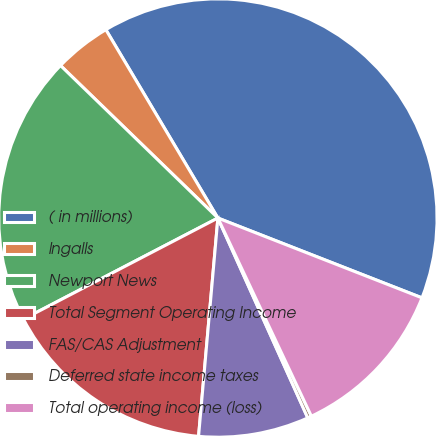Convert chart to OTSL. <chart><loc_0><loc_0><loc_500><loc_500><pie_chart><fcel>( in millions)<fcel>Ingalls<fcel>Newport News<fcel>Total Segment Operating Income<fcel>FAS/CAS Adjustment<fcel>Deferred state income taxes<fcel>Total operating income (loss)<nl><fcel>39.47%<fcel>4.21%<fcel>19.88%<fcel>15.96%<fcel>8.13%<fcel>0.29%<fcel>12.05%<nl></chart> 